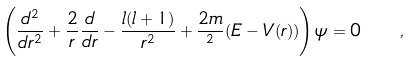Convert formula to latex. <formula><loc_0><loc_0><loc_500><loc_500>\left ( \frac { d ^ { 2 } } { d r ^ { 2 } } + \frac { 2 } { r } \frac { d } { d r } - \frac { l ( l + 1 ) } { r ^ { 2 } } + \frac { 2 m } { { } ^ { 2 } } ( E - V ( r ) ) \right ) \psi = 0 \quad ,</formula> 